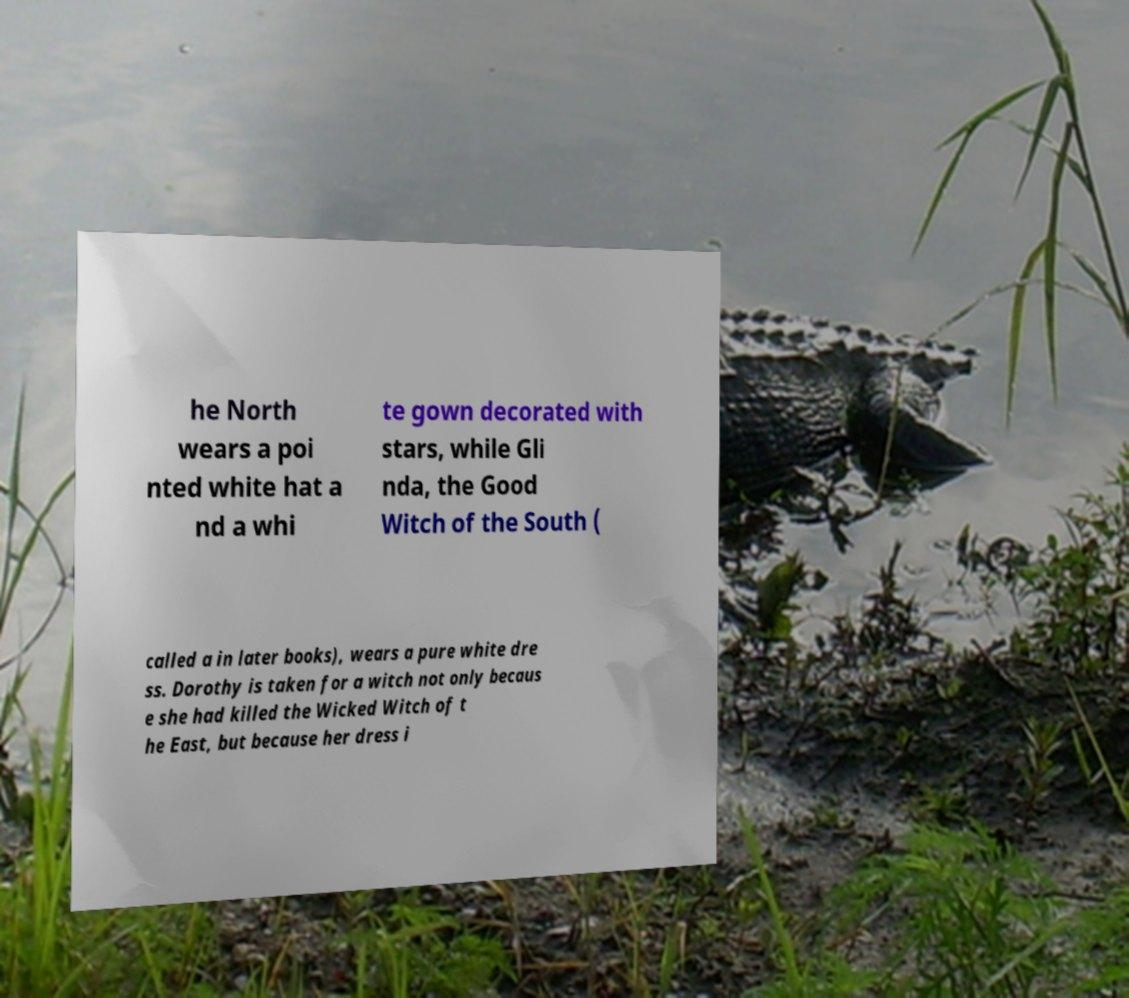Could you extract and type out the text from this image? he North wears a poi nted white hat a nd a whi te gown decorated with stars, while Gli nda, the Good Witch of the South ( called a in later books), wears a pure white dre ss. Dorothy is taken for a witch not only becaus e she had killed the Wicked Witch of t he East, but because her dress i 